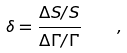Convert formula to latex. <formula><loc_0><loc_0><loc_500><loc_500>\delta = \frac { \Delta S / S } { \Delta \Gamma / \Gamma } \quad ,</formula> 